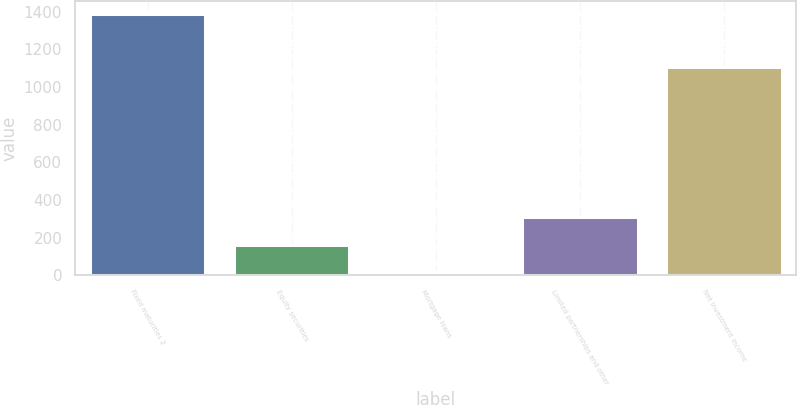Convert chart. <chart><loc_0><loc_0><loc_500><loc_500><bar_chart><fcel>Fixed maturities 2<fcel>Equity securities<fcel>Mortgage loans<fcel>Limited partnerships and other<fcel>Net investment income<nl><fcel>1386<fcel>163<fcel>16<fcel>310<fcel>1107<nl></chart> 